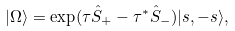Convert formula to latex. <formula><loc_0><loc_0><loc_500><loc_500>| \Omega \rangle = \exp ( \tau { \hat { S } } _ { + } - \tau ^ { * } { \hat { S } } _ { - } ) | s , - s \rangle ,</formula> 